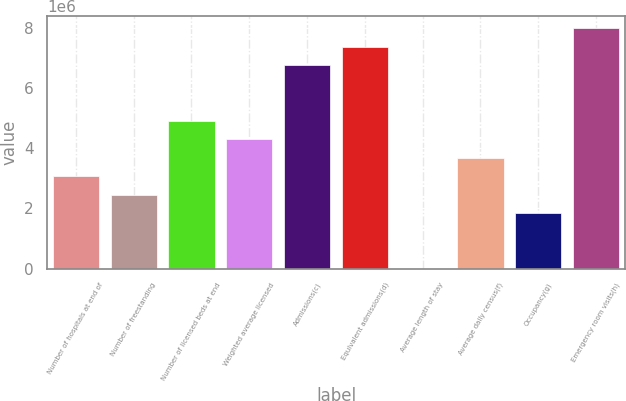<chart> <loc_0><loc_0><loc_500><loc_500><bar_chart><fcel>Number of hospitals at end of<fcel>Number of freestanding<fcel>Number of licensed beds at end<fcel>Weighted average licensed<fcel>Admissions(c)<fcel>Equivalent admissions(d)<fcel>Average length of stay<fcel>Average daily census(f)<fcel>Occupancy(g)<fcel>Emergency room visits(h)<nl><fcel>3.07175e+06<fcel>2.4574e+06<fcel>4.9148e+06<fcel>4.30045e+06<fcel>6.75785e+06<fcel>7.3722e+06<fcel>4.8<fcel>3.6861e+06<fcel>1.84305e+06<fcel>7.98655e+06<nl></chart> 